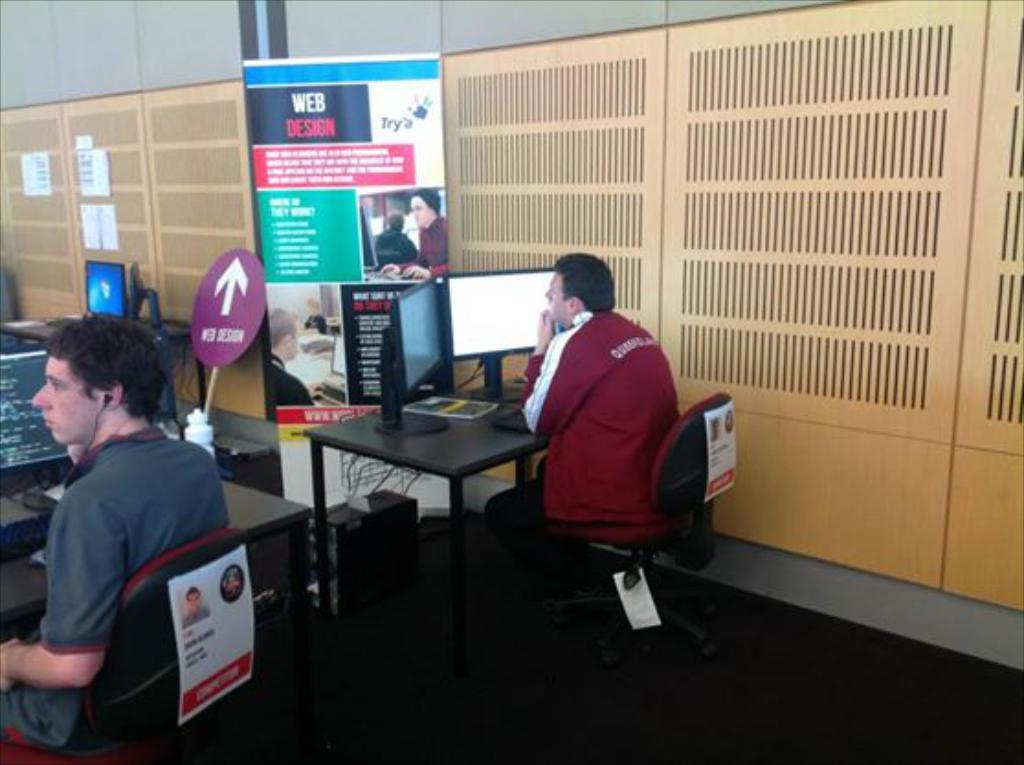How many people are in the image? There are two men in the image. What are the men doing in the image? The men are sitting in front of a table. What objects are on the table? There are desktops on the table. What can be seen on the wall behind the table? There is a wall with a banner on it. What type of lunch is being served to the children in the image? There are no children or lunch present in the image; it features two men sitting in front of a table with desktops. What riddle is written on the banner in the image? There is no riddle visible on the banner in the image; it only states that there is a banner on the wall. 